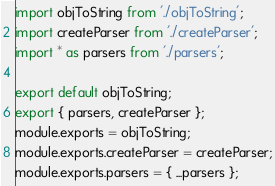<code> <loc_0><loc_0><loc_500><loc_500><_JavaScript_>import objToString from './objToString';
import createParser from './createParser';
import * as parsers from './parsers';

export default objToString;
export { parsers, createParser };
module.exports = objToString;
module.exports.createParser = createParser;
module.exports.parsers = { ...parsers };
</code> 